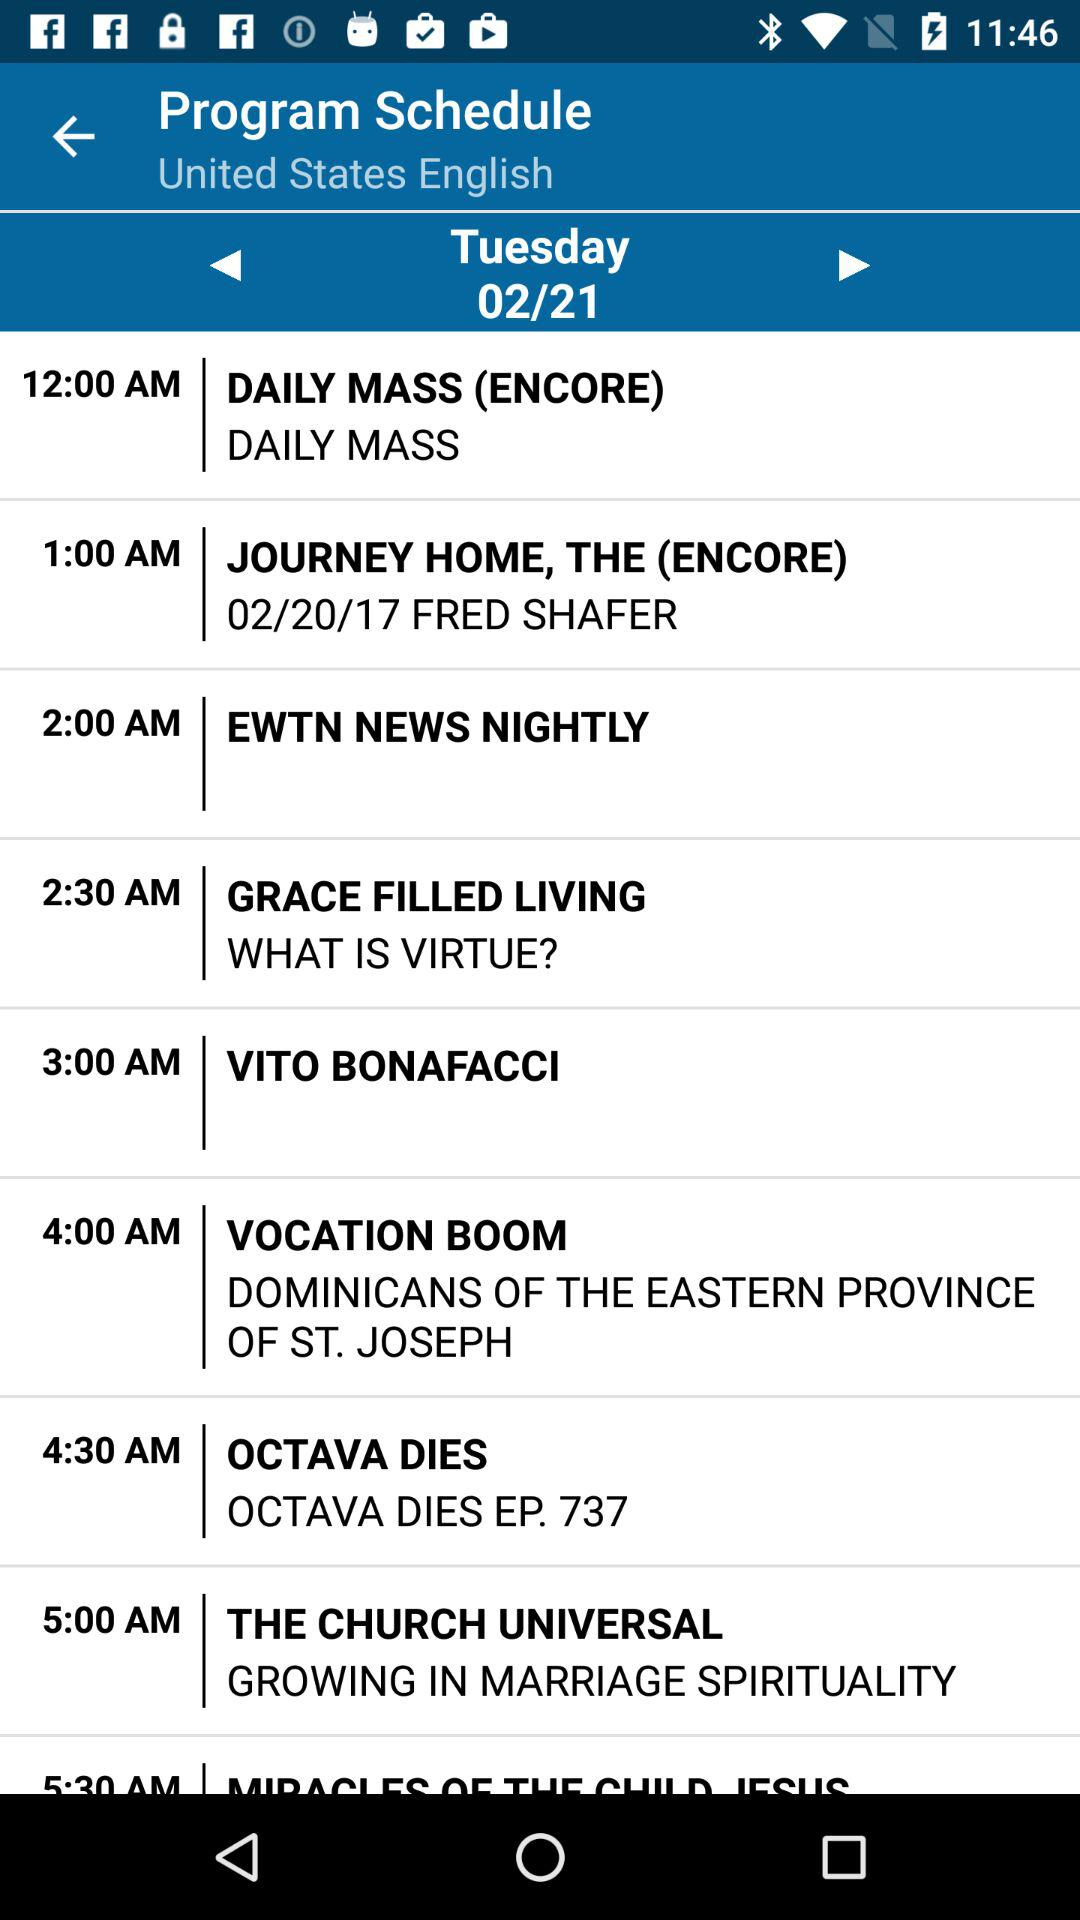What is the time of "GRACE FILLED LIVING"? The time of "GRACE FILLED LIVING" is 2:30 AM. 